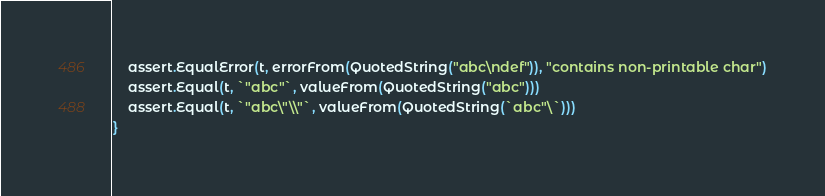<code> <loc_0><loc_0><loc_500><loc_500><_Go_>	assert.EqualError(t, errorFrom(QuotedString("abc\ndef")), "contains non-printable char")
	assert.Equal(t, `"abc"`, valueFrom(QuotedString("abc")))
	assert.Equal(t, `"abc\"\\"`, valueFrom(QuotedString(`abc"\`)))
}
</code> 